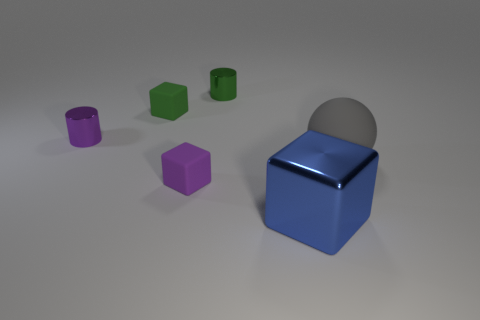Subtract all yellow cylinders. Subtract all blue blocks. How many cylinders are left? 2 Add 3 big gray matte spheres. How many objects exist? 9 Subtract all cylinders. How many objects are left? 4 Subtract 0 brown balls. How many objects are left? 6 Subtract all big rubber objects. Subtract all metallic objects. How many objects are left? 2 Add 3 small cylinders. How many small cylinders are left? 5 Add 1 small red balls. How many small red balls exist? 1 